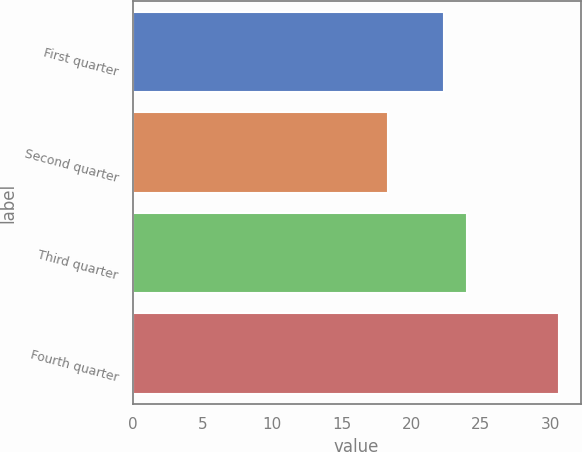<chart> <loc_0><loc_0><loc_500><loc_500><bar_chart><fcel>First quarter<fcel>Second quarter<fcel>Third quarter<fcel>Fourth quarter<nl><fcel>22.37<fcel>18.34<fcel>24.03<fcel>30.65<nl></chart> 